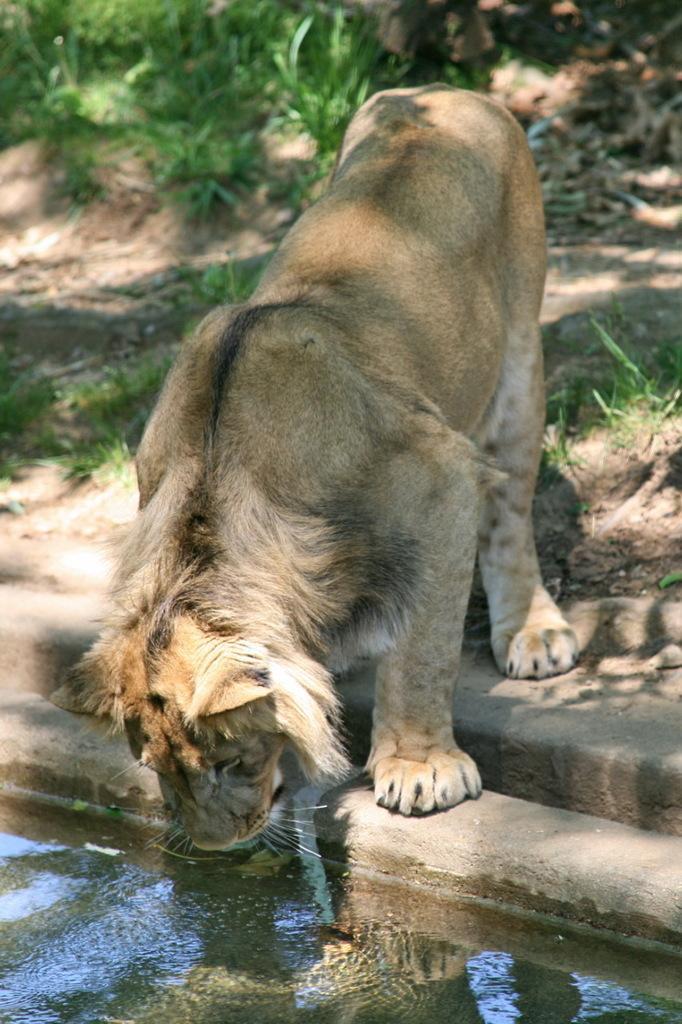Describe this image in one or two sentences. In this image we can see a lion. At the bottom there is water. In the back there are plants on the ground. 